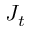Convert formula to latex. <formula><loc_0><loc_0><loc_500><loc_500>J _ { t }</formula> 